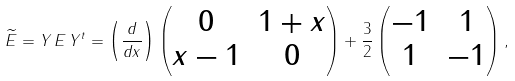Convert formula to latex. <formula><loc_0><loc_0><loc_500><loc_500>\widetilde { E } = Y \, E \, Y ^ { t } = \left ( \frac { d } { d x } \right ) \begin{pmatrix} 0 & 1 + x \\ x - 1 & 0 \end{pmatrix} + \frac { 3 } { 2 } \begin{pmatrix} - 1 & 1 \\ 1 & - 1 \end{pmatrix} ,</formula> 